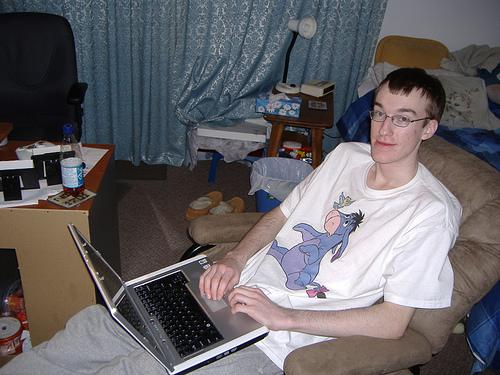Which children's author's creation does this man show off? Please explain your reasoning. aa milne. A man is wearing a shirt with a character from winnie the pooh which was written by aa milne. 